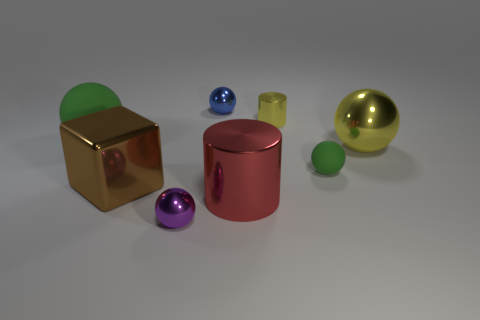What size is the cube?
Your response must be concise. Large. There is a tiny rubber thing that is the same color as the large matte sphere; what shape is it?
Ensure brevity in your answer.  Sphere. Is the number of brown metal objects greater than the number of tiny gray shiny spheres?
Your answer should be very brief. Yes. What is the color of the small metal sphere that is to the left of the object behind the tiny shiny object to the right of the red cylinder?
Your answer should be compact. Purple. There is a large metal object in front of the brown metal thing; does it have the same shape as the purple object?
Offer a terse response. No. The cylinder that is the same size as the blue metallic sphere is what color?
Offer a very short reply. Yellow. How many large cyan metallic spheres are there?
Ensure brevity in your answer.  0. Does the tiny ball behind the big metallic ball have the same material as the brown thing?
Your answer should be compact. Yes. The thing that is on the left side of the tiny purple thing and in front of the large green matte sphere is made of what material?
Your answer should be compact. Metal. There is a rubber sphere that is the same color as the tiny rubber thing; what is its size?
Your answer should be very brief. Large. 